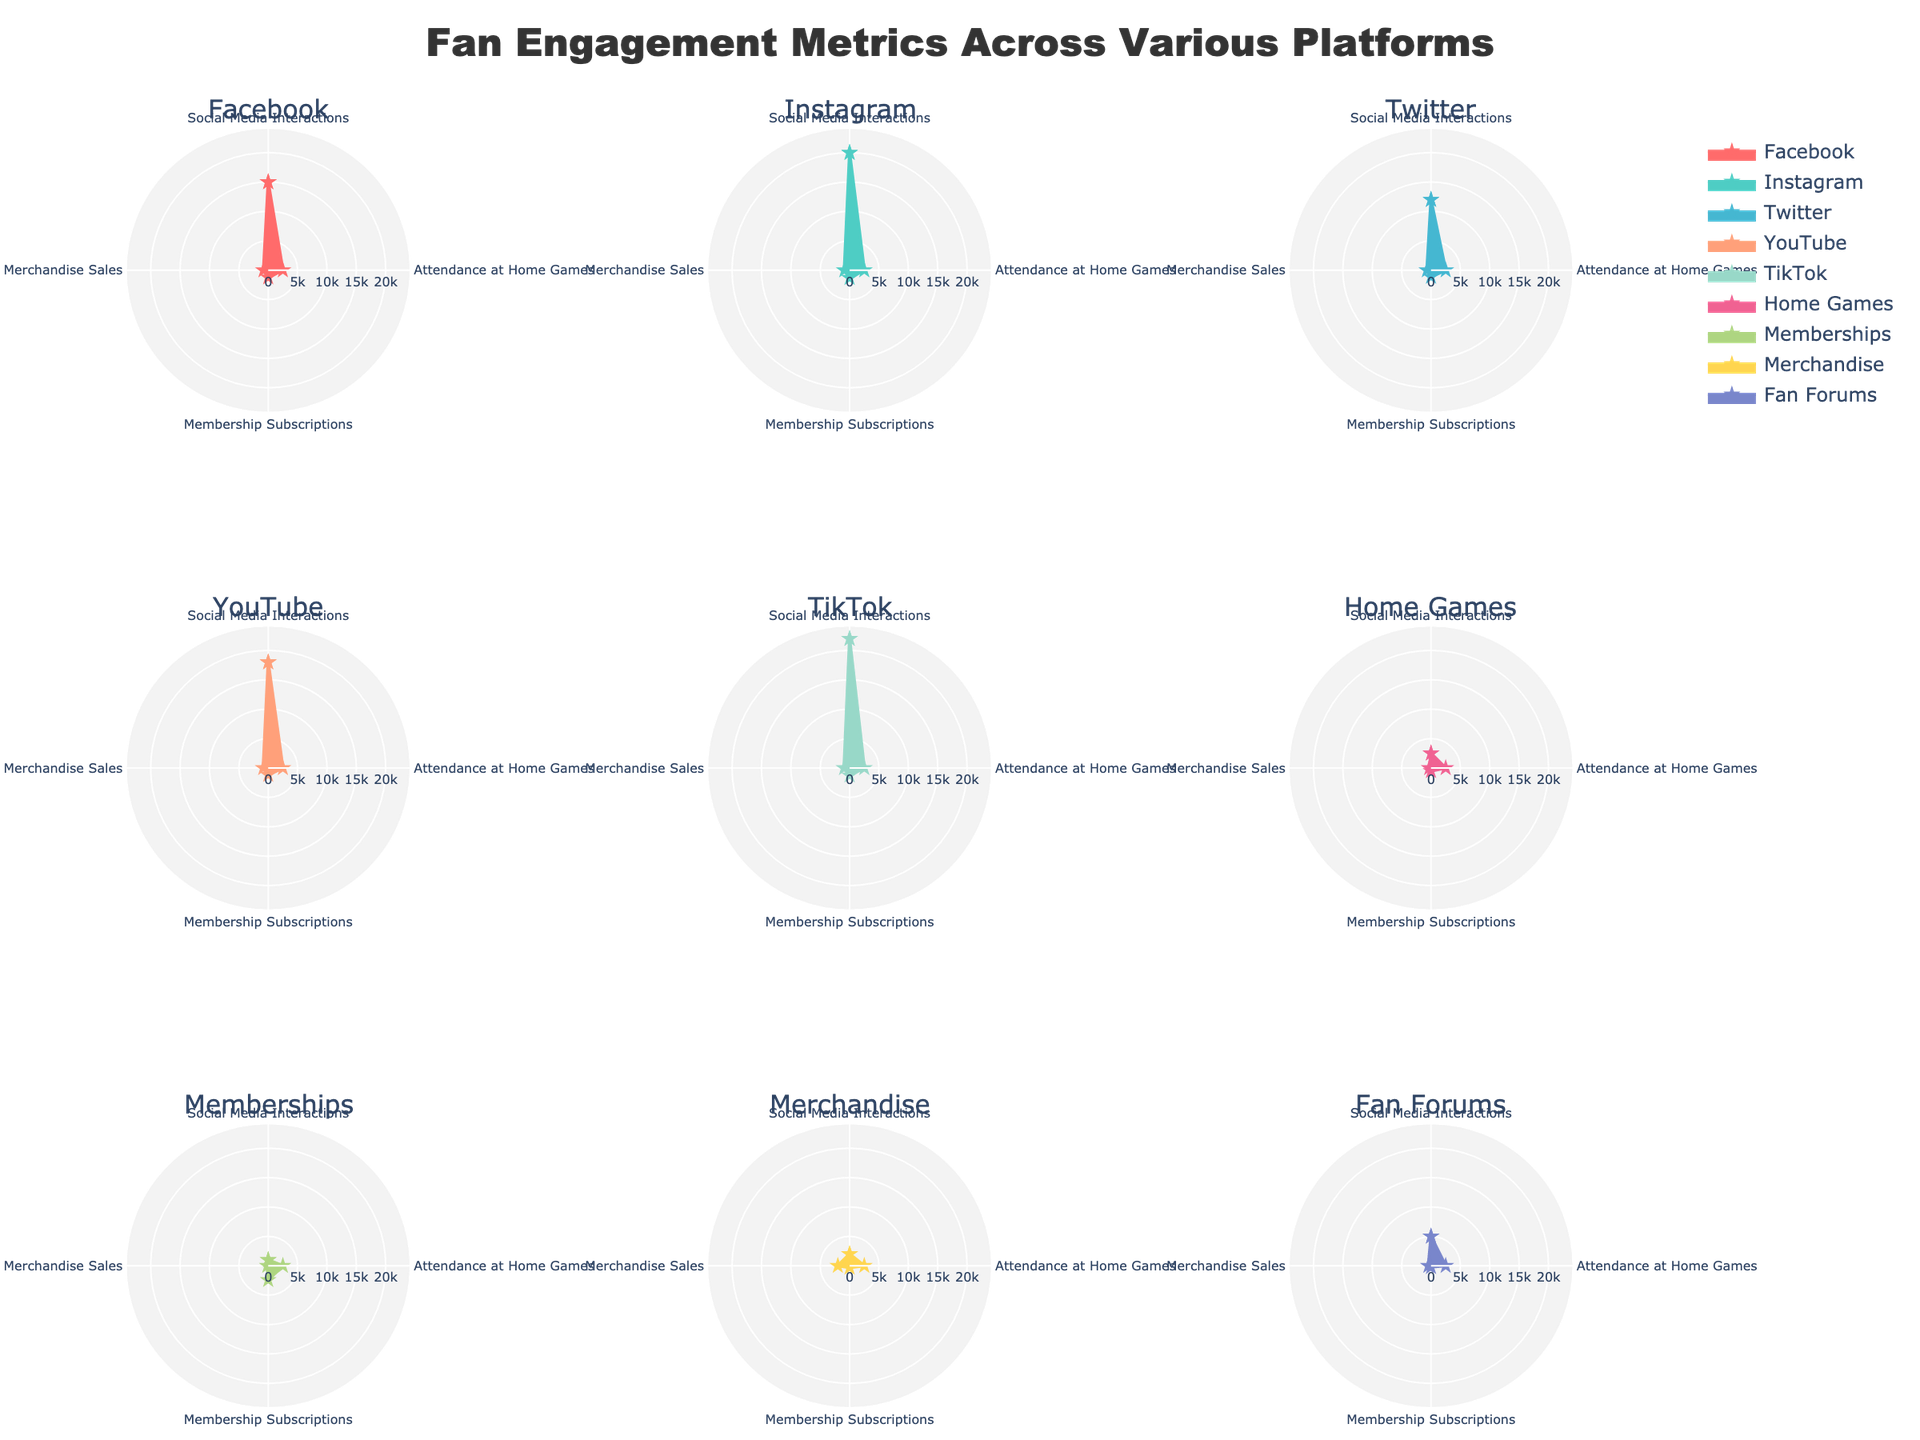What’s the maximum value for Social Media Interactions among the platforms? The figure shows radar charts of various platforms, each with different fan engagement metrics. By comparing the 'Social Media Interactions' axis for each platform, we can see that TikTok has the highest value.
Answer: TikTok Which platform shows the highest engagement in Membership Subscriptions? The radar chart for each platform includes a 'Membership Subscriptions' axis. By examining these axes, we see that the platform “Memberships” has the highest value in this metric.
Answer: Memberships Which platform has the lowest value for Merchandise Sales? Look at the 'Merchandise Sales' axis in the radar charts for all platforms. The lowest point on this axis appears in the radar chart for 'Memberships'.
Answer: Memberships Compare 'Membership Subscriptions' for Facebook and YouTube. Which one is higher? Check the radar charts for both Facebook and YouTube. The 'Membership Subscriptions' axis for YouTube is slightly higher than for Facebook.
Answer: YouTube What's the total of Attendance at Home Games across all platforms? Each radar chart shows 'Attendance at Home Games' with a fixed value of 2500 for all platforms. Since there are 9 platforms, the total attendance is 2500 * 9.
Answer: 22500 Which platform has the most balanced fan engagement across all metrics? The most balanced fan engagement can be interpreted as having the most uniform values in their radar chart. Instagram’s radar chart shows consistent values across all metrics without extreme highs or lows.
Answer: Instagram What’s the difference in Social Media Interactions between TikTok and Twitter? The radar charts show TikTok has 22000 and Twitter has 12000 in Social Media Interactions. The difference is 22000 - 12000.
Answer: 10000 Rank the platforms by their Merchandise Sales from highest to lowest. Check the 'Merchandise Sales' axis in each radar chart and list the values. The ranking from highest to lowest would be Merchandise > TikTok > Instagram > YouTube > Facebook > Fan Forums > Twitter > Memberships > Home Games.
Answer: Merchandise, TikTok, Instagram, YouTube, Facebook, Fan Forums, Twitter, Memberships, Home Games Which platform shows the highest positive Fan Sentiment? The radar charts are annotated with 'Fan Sentiment'. YouTube and Memberships have 'Very Positive' sentiment. Since YouTube is also high in other metrics, it appears to carry the highest overall positive sentiment.
Answer: YouTube 